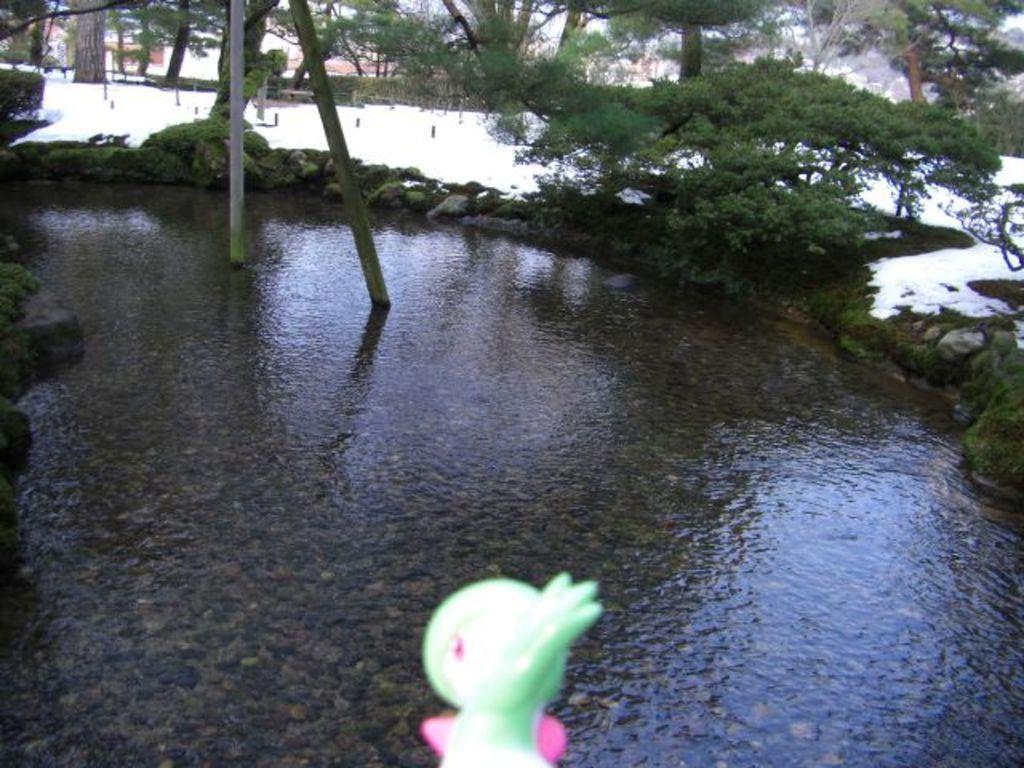How would you summarize this image in a sentence or two? This is water and there are poles. Here we can see plants, snow, and trees. 